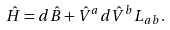Convert formula to latex. <formula><loc_0><loc_0><loc_500><loc_500>\hat { H } = d \hat { B } + \hat { V } ^ { a } d \hat { V } ^ { b } L _ { a b } .</formula> 